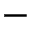Convert formula to latex. <formula><loc_0><loc_0><loc_500><loc_500>-</formula> 